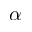Convert formula to latex. <formula><loc_0><loc_0><loc_500><loc_500>\alpha</formula> 